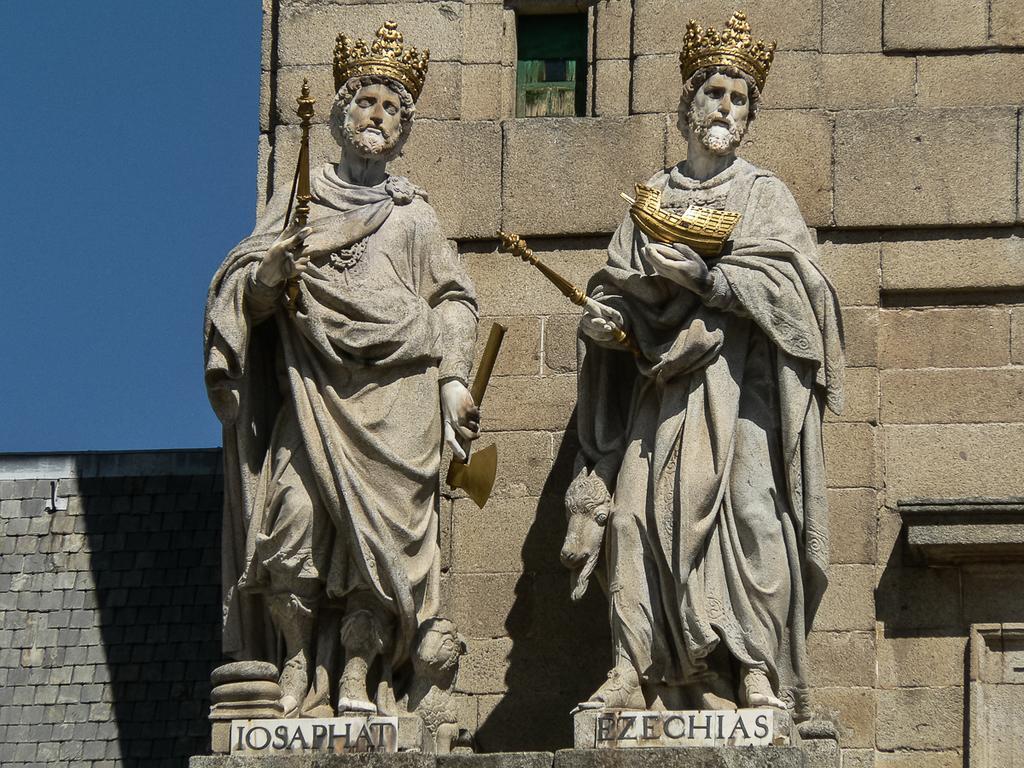Please provide a concise description of this image. In this image there are sculptures with names, behind the sculptures there is a wall. 